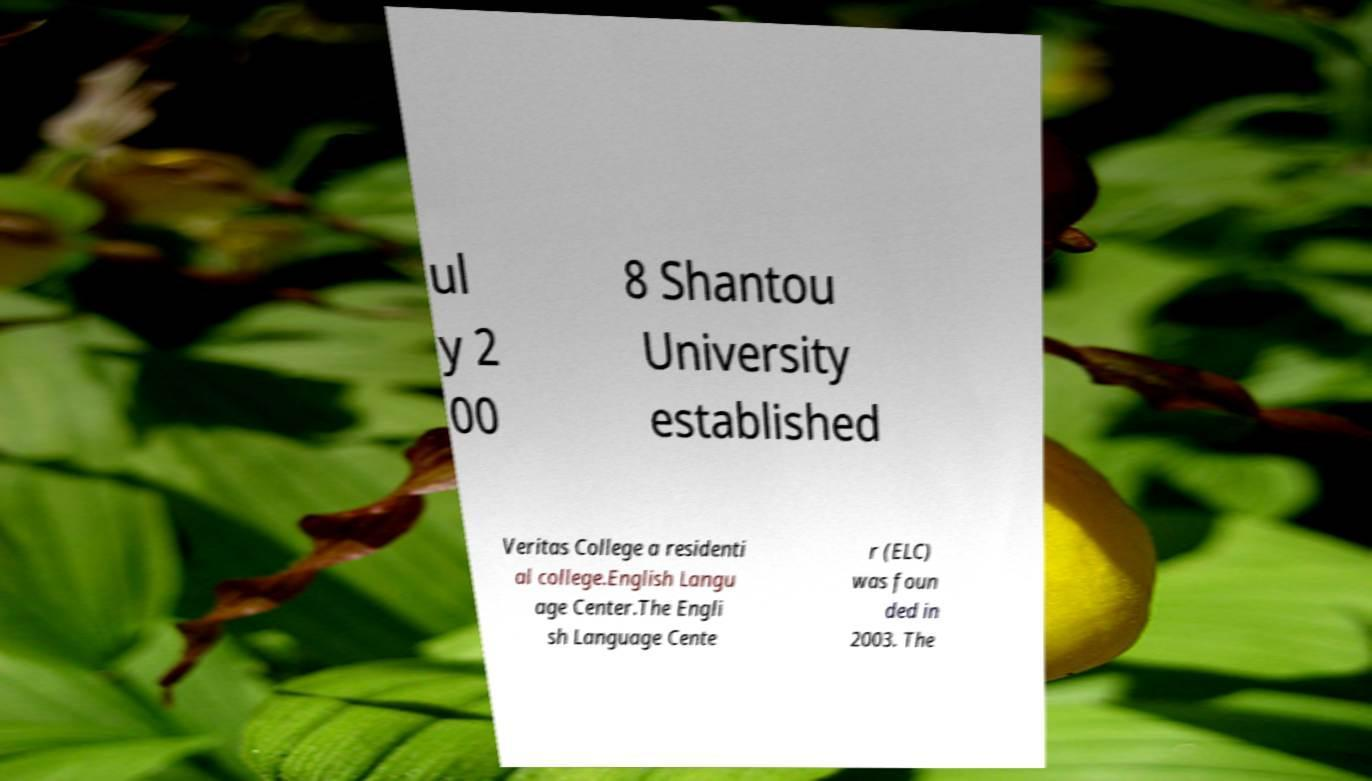Can you read and provide the text displayed in the image?This photo seems to have some interesting text. Can you extract and type it out for me? ul y 2 00 8 Shantou University established Veritas College a residenti al college.English Langu age Center.The Engli sh Language Cente r (ELC) was foun ded in 2003. The 